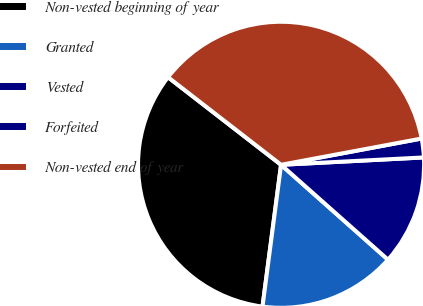Convert chart to OTSL. <chart><loc_0><loc_0><loc_500><loc_500><pie_chart><fcel>Non-vested beginning of year<fcel>Granted<fcel>Vested<fcel>Forfeited<fcel>Non-vested end of year<nl><fcel>33.42%<fcel>15.52%<fcel>12.37%<fcel>2.12%<fcel>36.57%<nl></chart> 